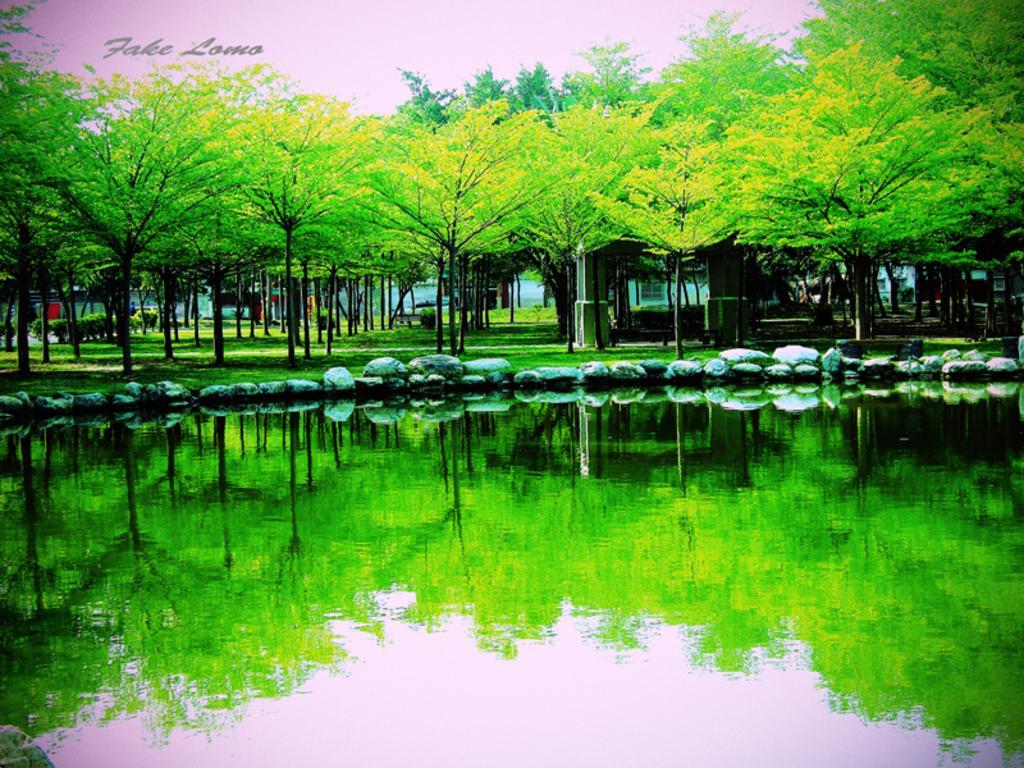Describe this image in one or two sentences. This is an edited image. At the bottom of the picture, we see water. In the middle of the picture, we see rocks and grass. There are trees and buildings in the background. 